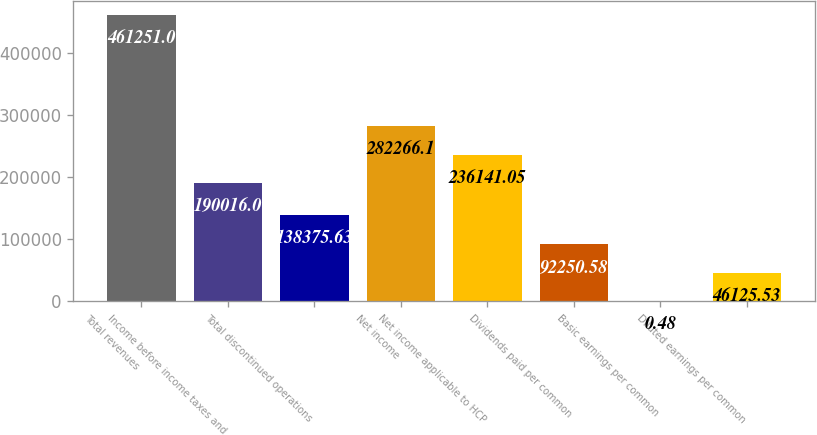Convert chart to OTSL. <chart><loc_0><loc_0><loc_500><loc_500><bar_chart><fcel>Total revenues<fcel>Income before income taxes and<fcel>Total discontinued operations<fcel>Net income<fcel>Net income applicable to HCP<fcel>Dividends paid per common<fcel>Basic earnings per common<fcel>Diluted earnings per common<nl><fcel>461251<fcel>190016<fcel>138376<fcel>282266<fcel>236141<fcel>92250.6<fcel>0.48<fcel>46125.5<nl></chart> 